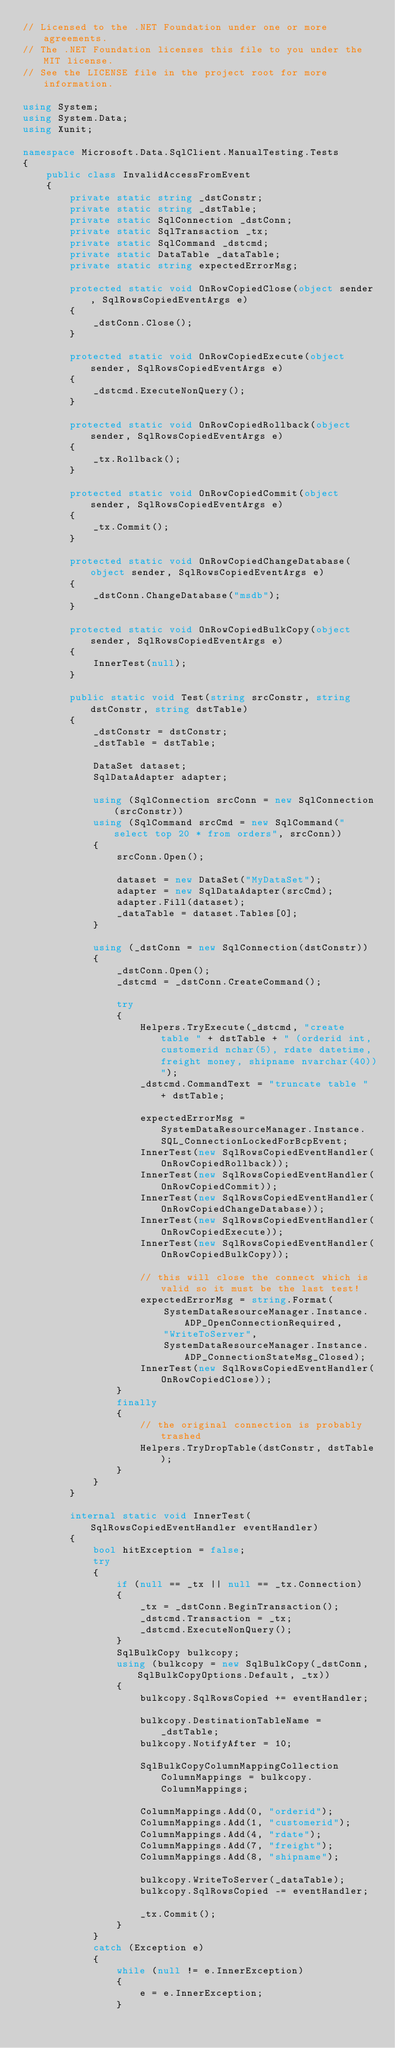Convert code to text. <code><loc_0><loc_0><loc_500><loc_500><_C#_>// Licensed to the .NET Foundation under one or more agreements.
// The .NET Foundation licenses this file to you under the MIT license.
// See the LICENSE file in the project root for more information.

using System;
using System.Data;
using Xunit;

namespace Microsoft.Data.SqlClient.ManualTesting.Tests
{
    public class InvalidAccessFromEvent
    {
        private static string _dstConstr;
        private static string _dstTable;
        private static SqlConnection _dstConn;
        private static SqlTransaction _tx;
        private static SqlCommand _dstcmd;
        private static DataTable _dataTable;
        private static string expectedErrorMsg;

        protected static void OnRowCopiedClose(object sender, SqlRowsCopiedEventArgs e)
        {
            _dstConn.Close();
        }

        protected static void OnRowCopiedExecute(object sender, SqlRowsCopiedEventArgs e)
        {
            _dstcmd.ExecuteNonQuery();
        }

        protected static void OnRowCopiedRollback(object sender, SqlRowsCopiedEventArgs e)
        {
            _tx.Rollback();
        }

        protected static void OnRowCopiedCommit(object sender, SqlRowsCopiedEventArgs e)
        {
            _tx.Commit();
        }

        protected static void OnRowCopiedChangeDatabase(object sender, SqlRowsCopiedEventArgs e)
        {
            _dstConn.ChangeDatabase("msdb");
        }

        protected static void OnRowCopiedBulkCopy(object sender, SqlRowsCopiedEventArgs e)
        {
            InnerTest(null);
        }

        public static void Test(string srcConstr, string dstConstr, string dstTable)
        {
            _dstConstr = dstConstr;
            _dstTable = dstTable;

            DataSet dataset;
            SqlDataAdapter adapter;

            using (SqlConnection srcConn = new SqlConnection(srcConstr))
            using (SqlCommand srcCmd = new SqlCommand("select top 20 * from orders", srcConn))
            {
                srcConn.Open();

                dataset = new DataSet("MyDataSet");
                adapter = new SqlDataAdapter(srcCmd);
                adapter.Fill(dataset);
                _dataTable = dataset.Tables[0];
            }

            using (_dstConn = new SqlConnection(dstConstr))
            {
                _dstConn.Open();
                _dstcmd = _dstConn.CreateCommand();

                try
                {
                    Helpers.TryExecute(_dstcmd, "create table " + dstTable + " (orderid int, customerid nchar(5), rdate datetime, freight money, shipname nvarchar(40))");
                    _dstcmd.CommandText = "truncate table " + dstTable;

                    expectedErrorMsg = SystemDataResourceManager.Instance.SQL_ConnectionLockedForBcpEvent;
                    InnerTest(new SqlRowsCopiedEventHandler(OnRowCopiedRollback));
                    InnerTest(new SqlRowsCopiedEventHandler(OnRowCopiedCommit));
                    InnerTest(new SqlRowsCopiedEventHandler(OnRowCopiedChangeDatabase));
                    InnerTest(new SqlRowsCopiedEventHandler(OnRowCopiedExecute));
                    InnerTest(new SqlRowsCopiedEventHandler(OnRowCopiedBulkCopy));

                    // this will close the connect which is valid so it must be the last test!
                    expectedErrorMsg = string.Format(
                        SystemDataResourceManager.Instance.ADP_OpenConnectionRequired,
                        "WriteToServer",
                        SystemDataResourceManager.Instance.ADP_ConnectionStateMsg_Closed);
                    InnerTest(new SqlRowsCopiedEventHandler(OnRowCopiedClose));
                }
                finally
                {
                    // the original connection is probably trashed
                    Helpers.TryDropTable(dstConstr, dstTable);
                }
            }
        }

        internal static void InnerTest(SqlRowsCopiedEventHandler eventHandler)
        {
            bool hitException = false;
            try
            {
                if (null == _tx || null == _tx.Connection)
                {
                    _tx = _dstConn.BeginTransaction();
                    _dstcmd.Transaction = _tx;
                    _dstcmd.ExecuteNonQuery();
                }
                SqlBulkCopy bulkcopy;
                using (bulkcopy = new SqlBulkCopy(_dstConn, SqlBulkCopyOptions.Default, _tx))
                {
                    bulkcopy.SqlRowsCopied += eventHandler;

                    bulkcopy.DestinationTableName = _dstTable;
                    bulkcopy.NotifyAfter = 10;

                    SqlBulkCopyColumnMappingCollection ColumnMappings = bulkcopy.ColumnMappings;

                    ColumnMappings.Add(0, "orderid");
                    ColumnMappings.Add(1, "customerid");
                    ColumnMappings.Add(4, "rdate");
                    ColumnMappings.Add(7, "freight");
                    ColumnMappings.Add(8, "shipname");

                    bulkcopy.WriteToServer(_dataTable);
                    bulkcopy.SqlRowsCopied -= eventHandler;

                    _tx.Commit();
                }
            }
            catch (Exception e)
            {
                while (null != e.InnerException)
                {
                    e = e.InnerException;
                }
</code> 